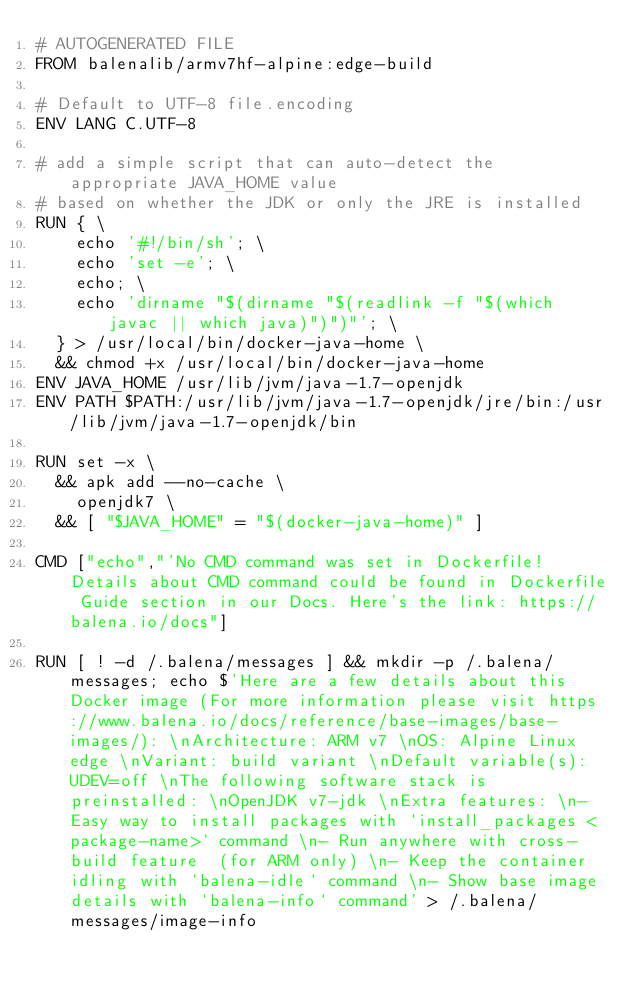<code> <loc_0><loc_0><loc_500><loc_500><_Dockerfile_># AUTOGENERATED FILE
FROM balenalib/armv7hf-alpine:edge-build

# Default to UTF-8 file.encoding
ENV LANG C.UTF-8

# add a simple script that can auto-detect the appropriate JAVA_HOME value
# based on whether the JDK or only the JRE is installed
RUN { \
		echo '#!/bin/sh'; \
		echo 'set -e'; \
		echo; \
		echo 'dirname "$(dirname "$(readlink -f "$(which javac || which java)")")"'; \
	} > /usr/local/bin/docker-java-home \
	&& chmod +x /usr/local/bin/docker-java-home
ENV JAVA_HOME /usr/lib/jvm/java-1.7-openjdk
ENV PATH $PATH:/usr/lib/jvm/java-1.7-openjdk/jre/bin:/usr/lib/jvm/java-1.7-openjdk/bin

RUN set -x \
	&& apk add --no-cache \
		openjdk7 \
	&& [ "$JAVA_HOME" = "$(docker-java-home)" ]

CMD ["echo","'No CMD command was set in Dockerfile! Details about CMD command could be found in Dockerfile Guide section in our Docs. Here's the link: https://balena.io/docs"]

RUN [ ! -d /.balena/messages ] && mkdir -p /.balena/messages; echo $'Here are a few details about this Docker image (For more information please visit https://www.balena.io/docs/reference/base-images/base-images/): \nArchitecture: ARM v7 \nOS: Alpine Linux edge \nVariant: build variant \nDefault variable(s): UDEV=off \nThe following software stack is preinstalled: \nOpenJDK v7-jdk \nExtra features: \n- Easy way to install packages with `install_packages <package-name>` command \n- Run anywhere with cross-build feature  (for ARM only) \n- Keep the container idling with `balena-idle` command \n- Show base image details with `balena-info` command' > /.balena/messages/image-info</code> 